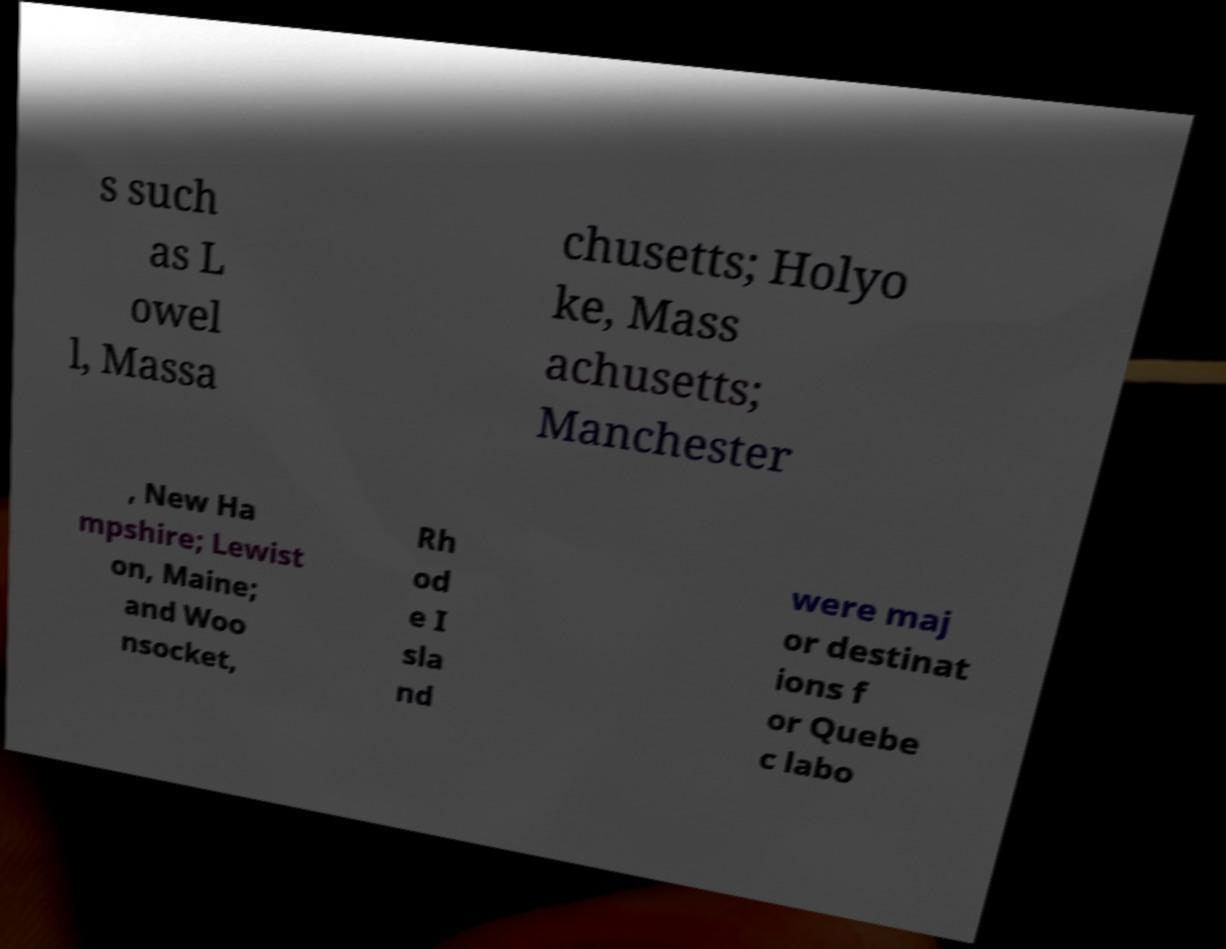Please identify and transcribe the text found in this image. s such as L owel l, Massa chusetts; Holyo ke, Mass achusetts; Manchester , New Ha mpshire; Lewist on, Maine; and Woo nsocket, Rh od e I sla nd were maj or destinat ions f or Quebe c labo 